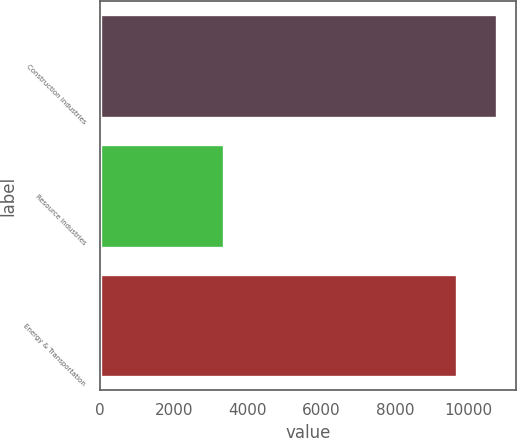Convert chart to OTSL. <chart><loc_0><loc_0><loc_500><loc_500><bar_chart><fcel>Construction Industries<fcel>Resource Industries<fcel>Energy & Transportation<nl><fcel>10754<fcel>3357<fcel>9685<nl></chart> 